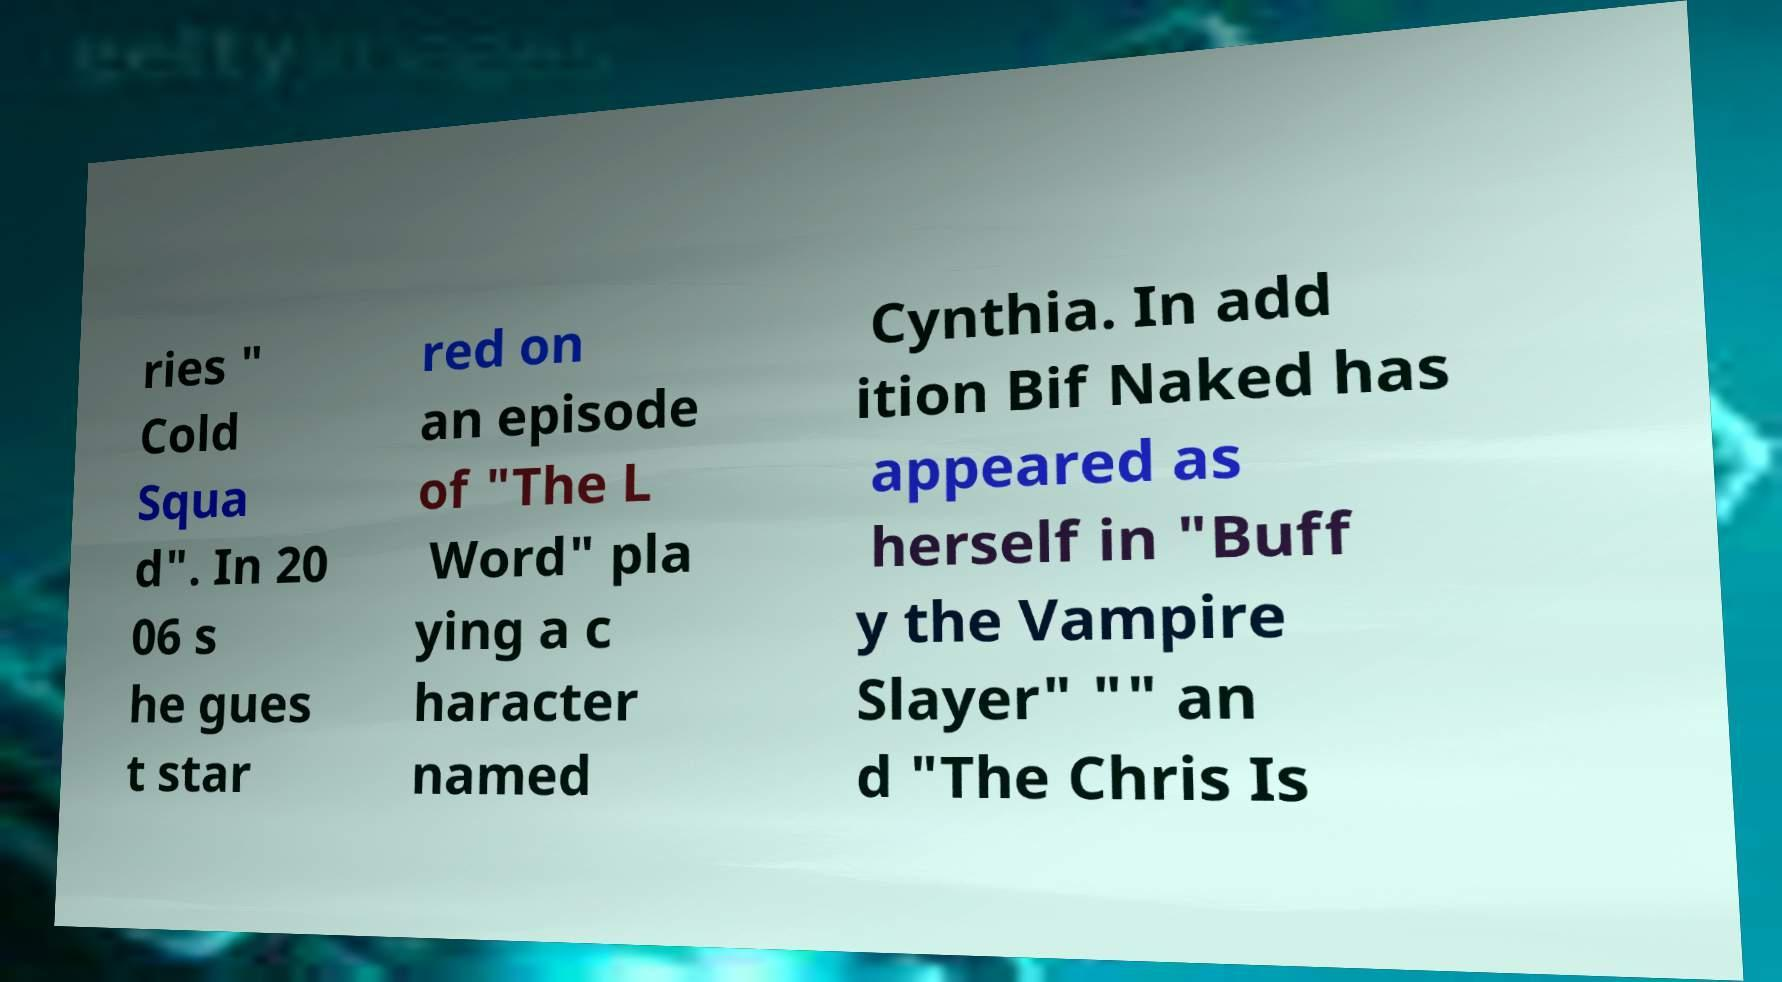I need the written content from this picture converted into text. Can you do that? ries " Cold Squa d". In 20 06 s he gues t star red on an episode of "The L Word" pla ying a c haracter named Cynthia. In add ition Bif Naked has appeared as herself in "Buff y the Vampire Slayer" "" an d "The Chris Is 